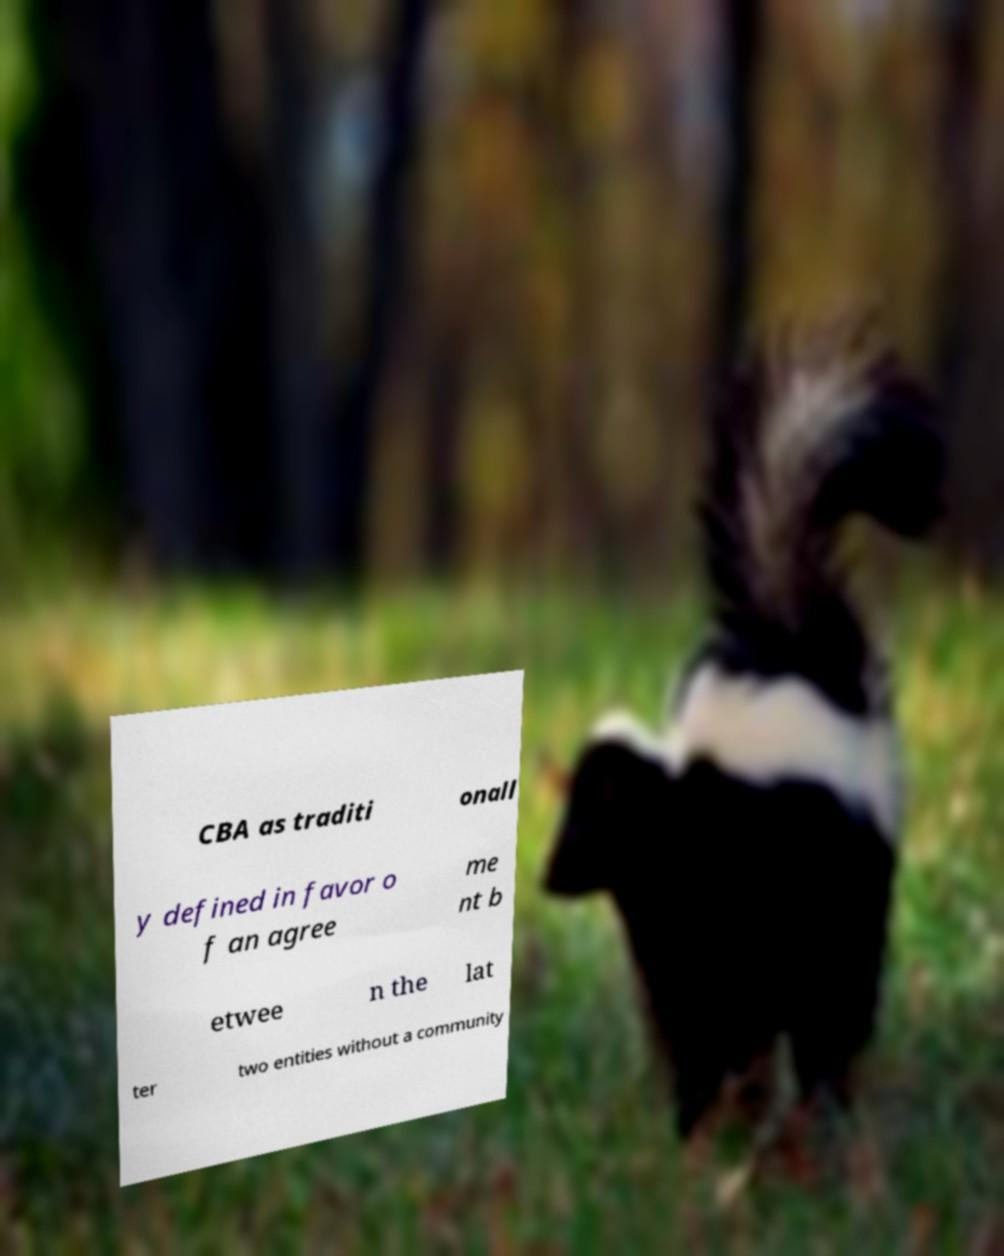Please identify and transcribe the text found in this image. CBA as traditi onall y defined in favor o f an agree me nt b etwee n the lat ter two entities without a community 